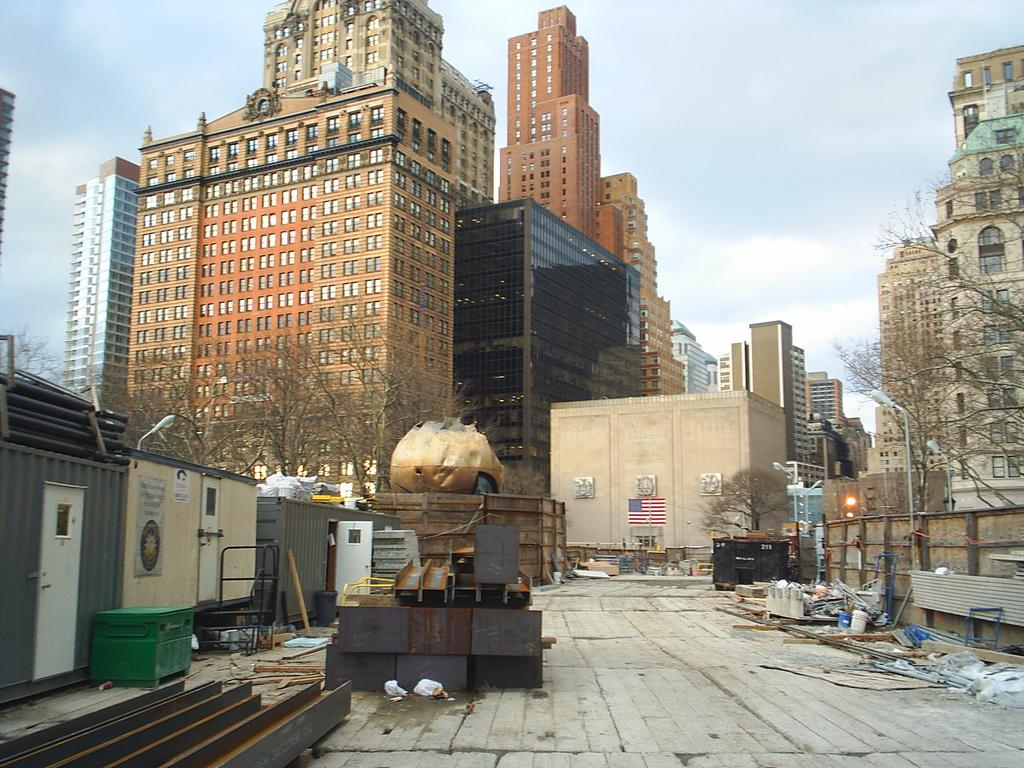What can be seen on the surface in the image? There are objects on the surface in the image. What is visible in the background of the image? There are buildings, trees, and street lights in the background of the image. What is visible at the top of the image? The sky is visible at the top of the image. How many beds can be seen in the image? There are no beds present in the image. Can you describe the lipstick worn by the fireman in the image? There is no fireman or lipstick present in the image. 